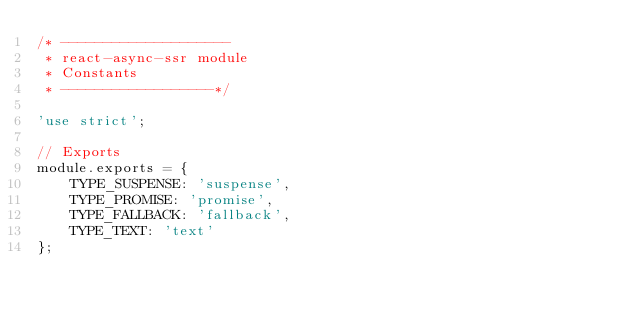<code> <loc_0><loc_0><loc_500><loc_500><_JavaScript_>/* --------------------
 * react-async-ssr module
 * Constants
 * ------------------*/

'use strict';

// Exports
module.exports = {
	TYPE_SUSPENSE: 'suspense',
	TYPE_PROMISE: 'promise',
	TYPE_FALLBACK: 'fallback',
	TYPE_TEXT: 'text'
};
</code> 